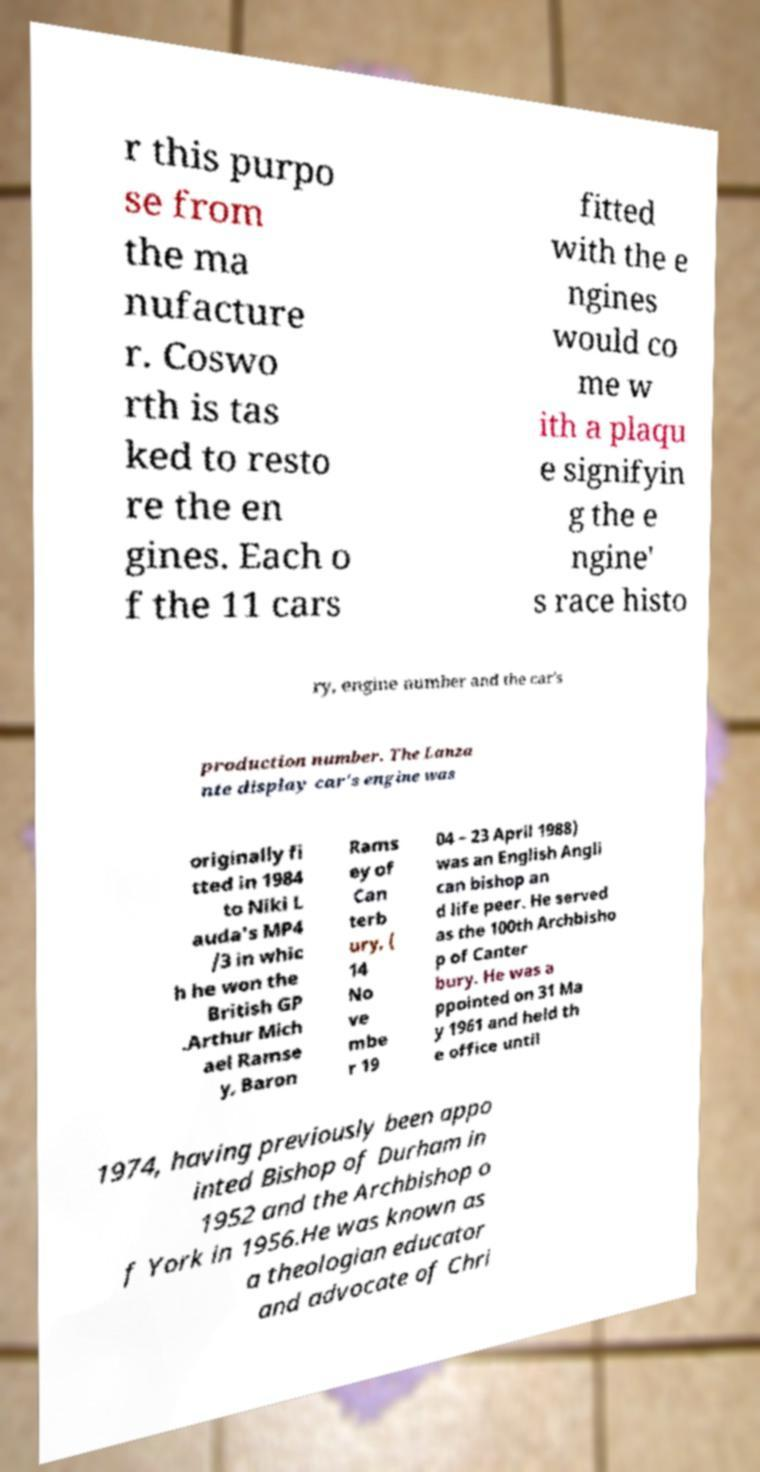Could you assist in decoding the text presented in this image and type it out clearly? r this purpo se from the ma nufacture r. Coswo rth is tas ked to resto re the en gines. Each o f the 11 cars fitted with the e ngines would co me w ith a plaqu e signifyin g the e ngine' s race histo ry, engine number and the car's production number. The Lanza nte display car's engine was originally fi tted in 1984 to Niki L auda's MP4 /3 in whic h he won the British GP .Arthur Mich ael Ramse y, Baron Rams ey of Can terb ury, ( 14 No ve mbe r 19 04 – 23 April 1988) was an English Angli can bishop an d life peer. He served as the 100th Archbisho p of Canter bury. He was a ppointed on 31 Ma y 1961 and held th e office until 1974, having previously been appo inted Bishop of Durham in 1952 and the Archbishop o f York in 1956.He was known as a theologian educator and advocate of Chri 